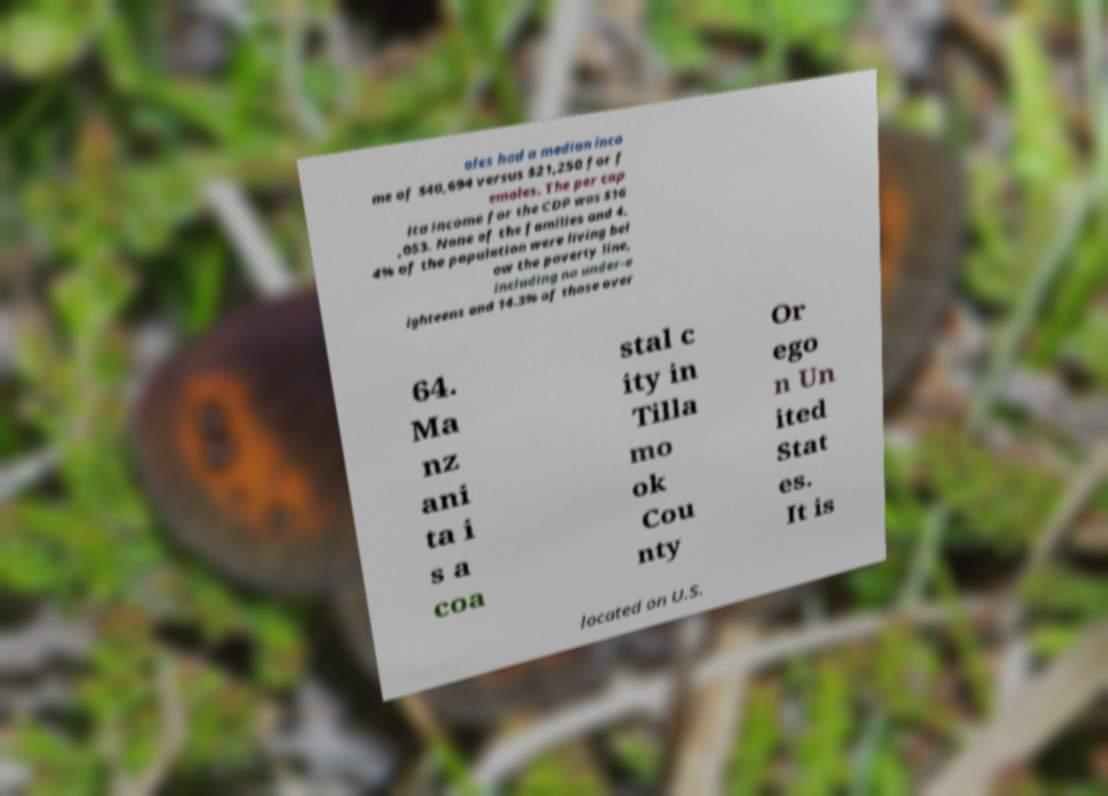For documentation purposes, I need the text within this image transcribed. Could you provide that? ales had a median inco me of $40,694 versus $21,250 for f emales. The per cap ita income for the CDP was $16 ,053. None of the families and 4. 4% of the population were living bel ow the poverty line, including no under-e ighteens and 14.3% of those over 64. Ma nz ani ta i s a coa stal c ity in Tilla mo ok Cou nty Or ego n Un ited Stat es. It is located on U.S. 